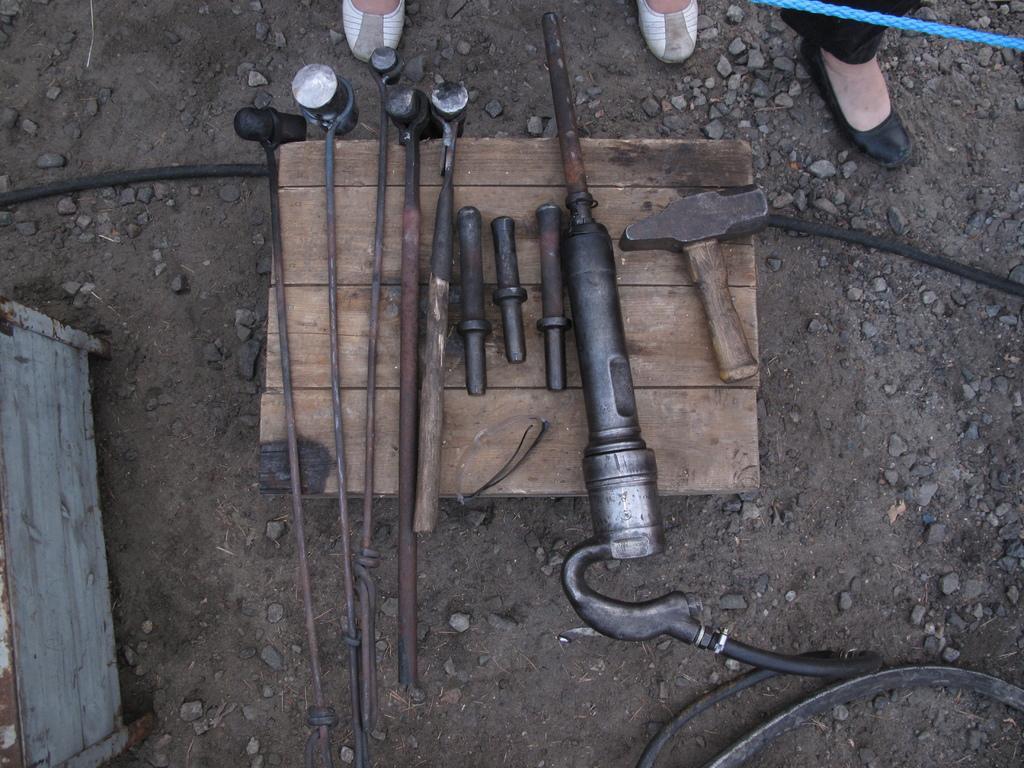How would you summarize this image in a sentence or two? In this picture we can see a few tools on a wooden object. We can see a few stones and other objects are visible on the ground. There is an object visible on the left side. We can see the feet of a few people. There is a blue object visible in the top right. 